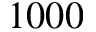<formula> <loc_0><loc_0><loc_500><loc_500>1 0 0 0</formula> 